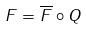<formula> <loc_0><loc_0><loc_500><loc_500>F = \overline { F } \circ Q</formula> 